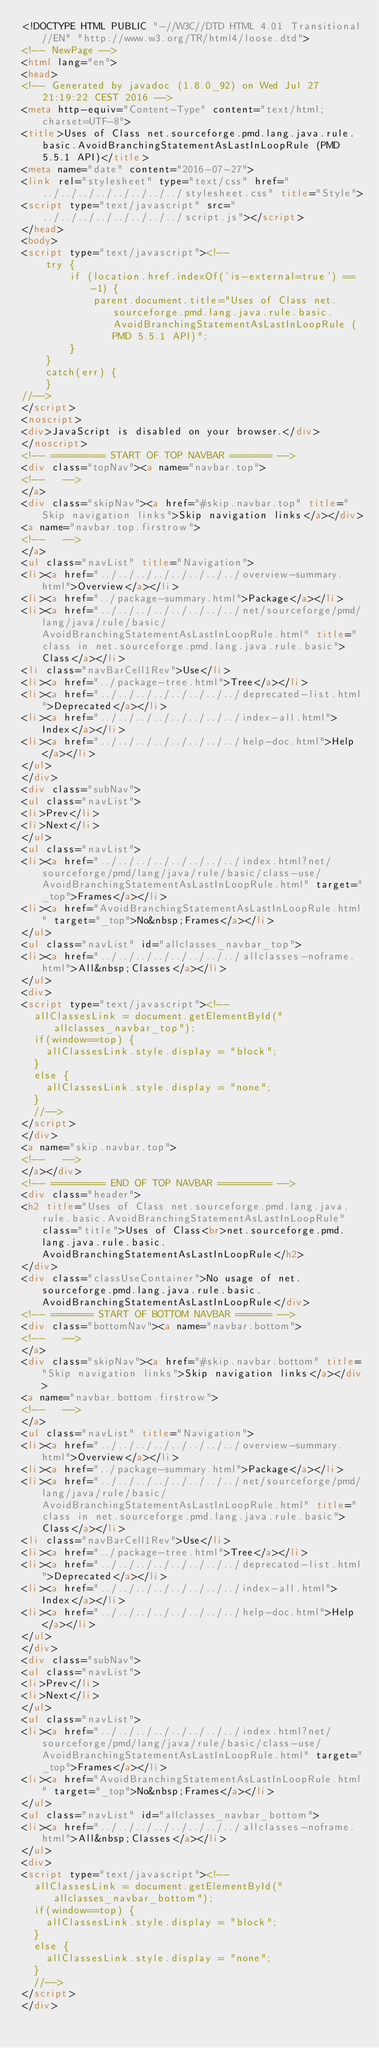Convert code to text. <code><loc_0><loc_0><loc_500><loc_500><_HTML_><!DOCTYPE HTML PUBLIC "-//W3C//DTD HTML 4.01 Transitional//EN" "http://www.w3.org/TR/html4/loose.dtd">
<!-- NewPage -->
<html lang="en">
<head>
<!-- Generated by javadoc (1.8.0_92) on Wed Jul 27 21:19:22 CEST 2016 -->
<meta http-equiv="Content-Type" content="text/html; charset=UTF-8">
<title>Uses of Class net.sourceforge.pmd.lang.java.rule.basic.AvoidBranchingStatementAsLastInLoopRule (PMD 5.5.1 API)</title>
<meta name="date" content="2016-07-27">
<link rel="stylesheet" type="text/css" href="../../../../../../../../stylesheet.css" title="Style">
<script type="text/javascript" src="../../../../../../../../script.js"></script>
</head>
<body>
<script type="text/javascript"><!--
    try {
        if (location.href.indexOf('is-external=true') == -1) {
            parent.document.title="Uses of Class net.sourceforge.pmd.lang.java.rule.basic.AvoidBranchingStatementAsLastInLoopRule (PMD 5.5.1 API)";
        }
    }
    catch(err) {
    }
//-->
</script>
<noscript>
<div>JavaScript is disabled on your browser.</div>
</noscript>
<!-- ========= START OF TOP NAVBAR ======= -->
<div class="topNav"><a name="navbar.top">
<!--   -->
</a>
<div class="skipNav"><a href="#skip.navbar.top" title="Skip navigation links">Skip navigation links</a></div>
<a name="navbar.top.firstrow">
<!--   -->
</a>
<ul class="navList" title="Navigation">
<li><a href="../../../../../../../../overview-summary.html">Overview</a></li>
<li><a href="../package-summary.html">Package</a></li>
<li><a href="../../../../../../../../net/sourceforge/pmd/lang/java/rule/basic/AvoidBranchingStatementAsLastInLoopRule.html" title="class in net.sourceforge.pmd.lang.java.rule.basic">Class</a></li>
<li class="navBarCell1Rev">Use</li>
<li><a href="../package-tree.html">Tree</a></li>
<li><a href="../../../../../../../../deprecated-list.html">Deprecated</a></li>
<li><a href="../../../../../../../../index-all.html">Index</a></li>
<li><a href="../../../../../../../../help-doc.html">Help</a></li>
</ul>
</div>
<div class="subNav">
<ul class="navList">
<li>Prev</li>
<li>Next</li>
</ul>
<ul class="navList">
<li><a href="../../../../../../../../index.html?net/sourceforge/pmd/lang/java/rule/basic/class-use/AvoidBranchingStatementAsLastInLoopRule.html" target="_top">Frames</a></li>
<li><a href="AvoidBranchingStatementAsLastInLoopRule.html" target="_top">No&nbsp;Frames</a></li>
</ul>
<ul class="navList" id="allclasses_navbar_top">
<li><a href="../../../../../../../../allclasses-noframe.html">All&nbsp;Classes</a></li>
</ul>
<div>
<script type="text/javascript"><!--
  allClassesLink = document.getElementById("allclasses_navbar_top");
  if(window==top) {
    allClassesLink.style.display = "block";
  }
  else {
    allClassesLink.style.display = "none";
  }
  //-->
</script>
</div>
<a name="skip.navbar.top">
<!--   -->
</a></div>
<!-- ========= END OF TOP NAVBAR ========= -->
<div class="header">
<h2 title="Uses of Class net.sourceforge.pmd.lang.java.rule.basic.AvoidBranchingStatementAsLastInLoopRule" class="title">Uses of Class<br>net.sourceforge.pmd.lang.java.rule.basic.AvoidBranchingStatementAsLastInLoopRule</h2>
</div>
<div class="classUseContainer">No usage of net.sourceforge.pmd.lang.java.rule.basic.AvoidBranchingStatementAsLastInLoopRule</div>
<!-- ======= START OF BOTTOM NAVBAR ====== -->
<div class="bottomNav"><a name="navbar.bottom">
<!--   -->
</a>
<div class="skipNav"><a href="#skip.navbar.bottom" title="Skip navigation links">Skip navigation links</a></div>
<a name="navbar.bottom.firstrow">
<!--   -->
</a>
<ul class="navList" title="Navigation">
<li><a href="../../../../../../../../overview-summary.html">Overview</a></li>
<li><a href="../package-summary.html">Package</a></li>
<li><a href="../../../../../../../../net/sourceforge/pmd/lang/java/rule/basic/AvoidBranchingStatementAsLastInLoopRule.html" title="class in net.sourceforge.pmd.lang.java.rule.basic">Class</a></li>
<li class="navBarCell1Rev">Use</li>
<li><a href="../package-tree.html">Tree</a></li>
<li><a href="../../../../../../../../deprecated-list.html">Deprecated</a></li>
<li><a href="../../../../../../../../index-all.html">Index</a></li>
<li><a href="../../../../../../../../help-doc.html">Help</a></li>
</ul>
</div>
<div class="subNav">
<ul class="navList">
<li>Prev</li>
<li>Next</li>
</ul>
<ul class="navList">
<li><a href="../../../../../../../../index.html?net/sourceforge/pmd/lang/java/rule/basic/class-use/AvoidBranchingStatementAsLastInLoopRule.html" target="_top">Frames</a></li>
<li><a href="AvoidBranchingStatementAsLastInLoopRule.html" target="_top">No&nbsp;Frames</a></li>
</ul>
<ul class="navList" id="allclasses_navbar_bottom">
<li><a href="../../../../../../../../allclasses-noframe.html">All&nbsp;Classes</a></li>
</ul>
<div>
<script type="text/javascript"><!--
  allClassesLink = document.getElementById("allclasses_navbar_bottom");
  if(window==top) {
    allClassesLink.style.display = "block";
  }
  else {
    allClassesLink.style.display = "none";
  }
  //-->
</script>
</div></code> 